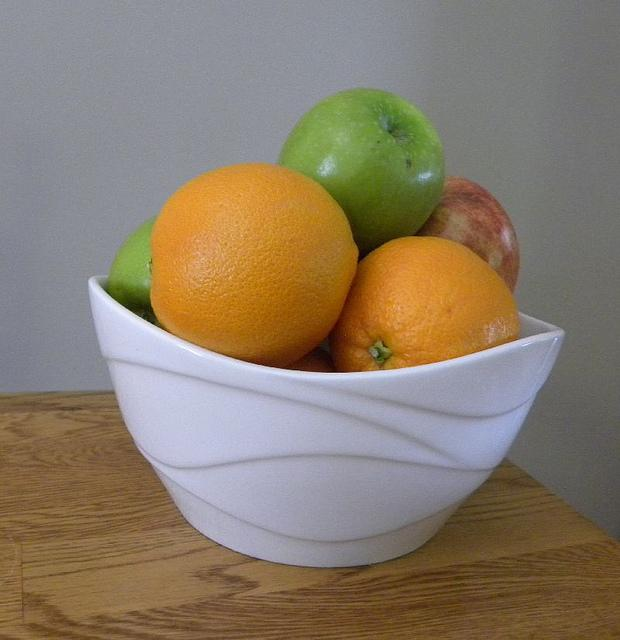What color skin does the tartest fruit seen here have? orange 